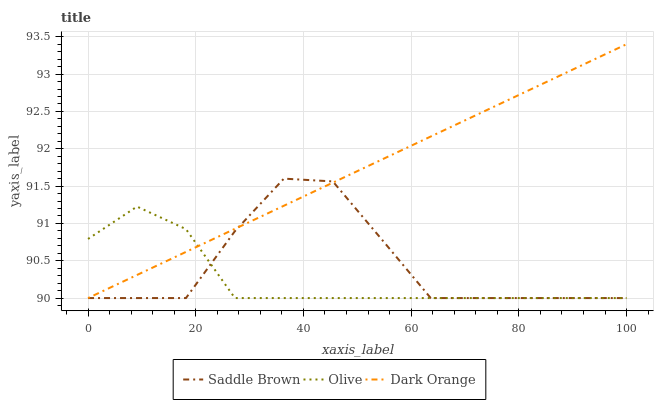Does Olive have the minimum area under the curve?
Answer yes or no. Yes. Does Dark Orange have the maximum area under the curve?
Answer yes or no. Yes. Does Saddle Brown have the minimum area under the curve?
Answer yes or no. No. Does Saddle Brown have the maximum area under the curve?
Answer yes or no. No. Is Dark Orange the smoothest?
Answer yes or no. Yes. Is Saddle Brown the roughest?
Answer yes or no. Yes. Is Saddle Brown the smoothest?
Answer yes or no. No. Is Dark Orange the roughest?
Answer yes or no. No. Does Olive have the lowest value?
Answer yes or no. Yes. Does Dark Orange have the highest value?
Answer yes or no. Yes. Does Saddle Brown have the highest value?
Answer yes or no. No. Does Saddle Brown intersect Olive?
Answer yes or no. Yes. Is Saddle Brown less than Olive?
Answer yes or no. No. Is Saddle Brown greater than Olive?
Answer yes or no. No. 